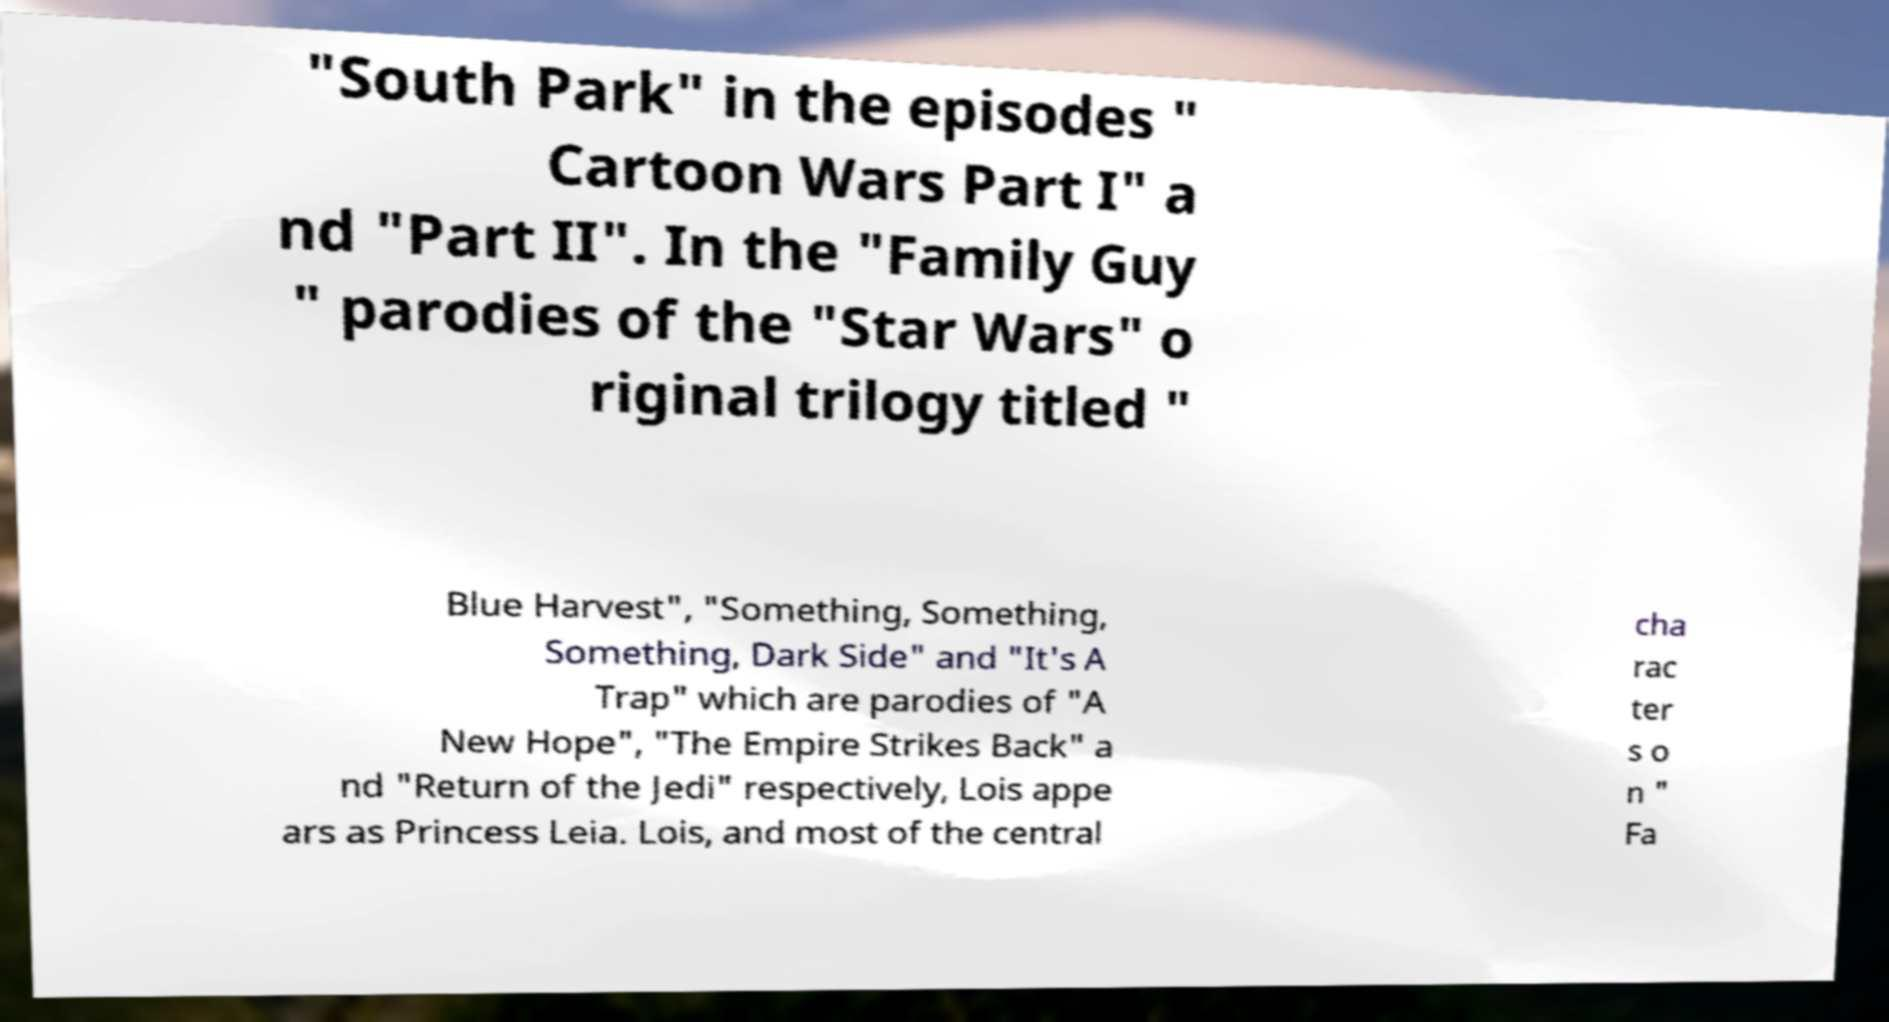What messages or text are displayed in this image? I need them in a readable, typed format. "South Park" in the episodes " Cartoon Wars Part I" a nd "Part II". In the "Family Guy " parodies of the "Star Wars" o riginal trilogy titled " Blue Harvest", "Something, Something, Something, Dark Side" and "It's A Trap" which are parodies of "A New Hope", "The Empire Strikes Back" a nd "Return of the Jedi" respectively, Lois appe ars as Princess Leia. Lois, and most of the central cha rac ter s o n " Fa 